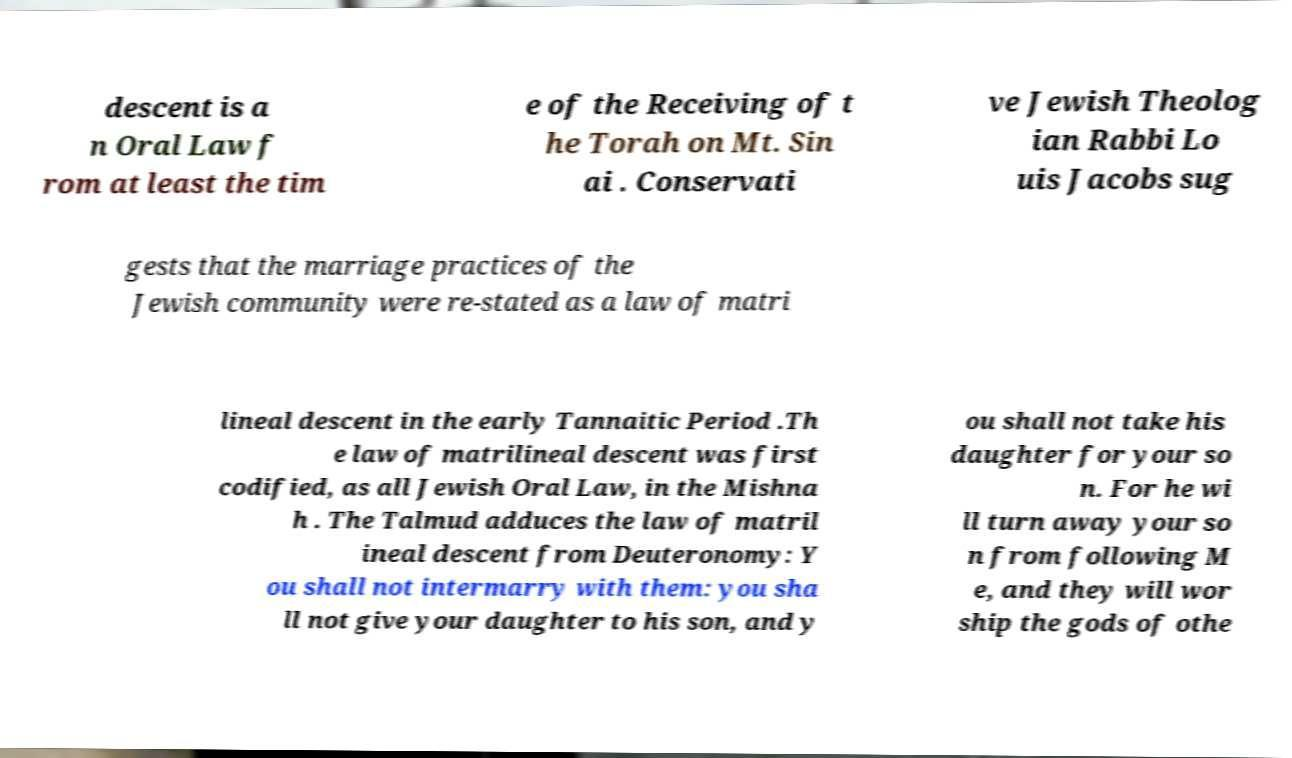For documentation purposes, I need the text within this image transcribed. Could you provide that? descent is a n Oral Law f rom at least the tim e of the Receiving of t he Torah on Mt. Sin ai . Conservati ve Jewish Theolog ian Rabbi Lo uis Jacobs sug gests that the marriage practices of the Jewish community were re-stated as a law of matri lineal descent in the early Tannaitic Period .Th e law of matrilineal descent was first codified, as all Jewish Oral Law, in the Mishna h . The Talmud adduces the law of matril ineal descent from Deuteronomy: Y ou shall not intermarry with them: you sha ll not give your daughter to his son, and y ou shall not take his daughter for your so n. For he wi ll turn away your so n from following M e, and they will wor ship the gods of othe 